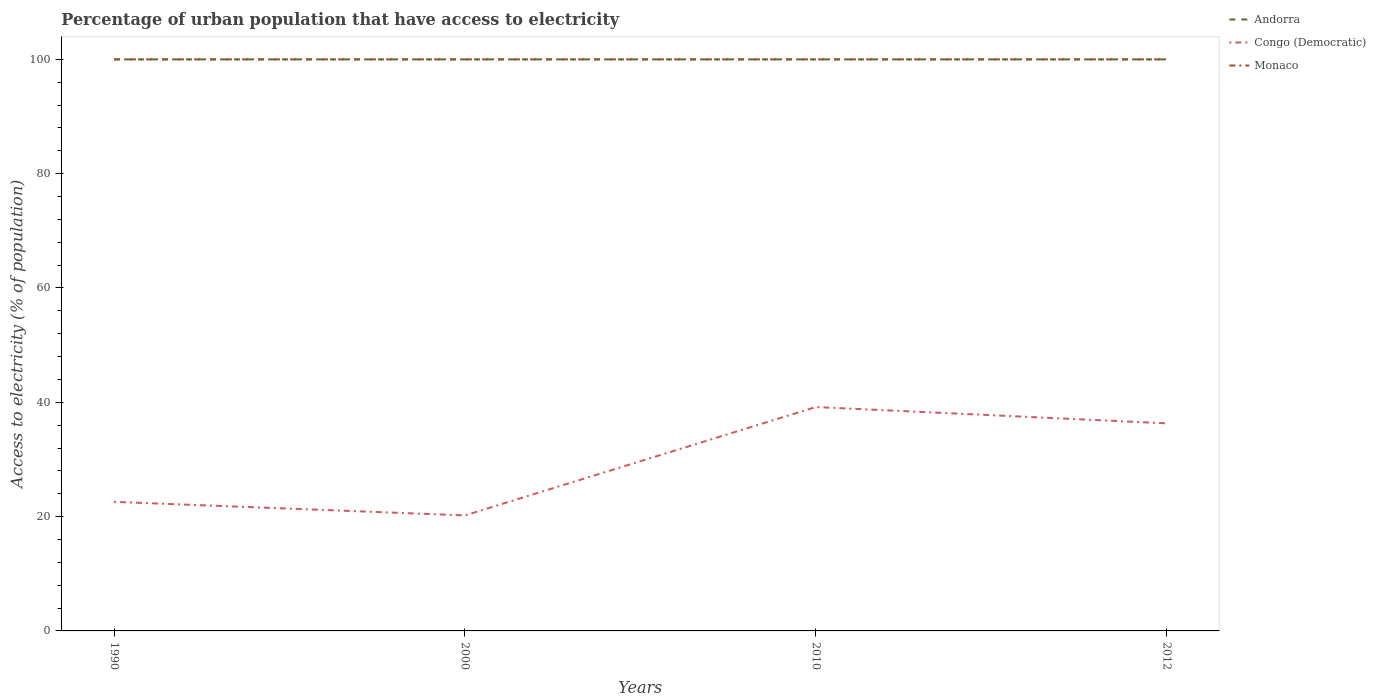How many different coloured lines are there?
Your response must be concise. 3. Does the line corresponding to Congo (Democratic) intersect with the line corresponding to Monaco?
Provide a succinct answer. No. Across all years, what is the maximum percentage of urban population that have access to electricity in Andorra?
Give a very brief answer. 100. What is the total percentage of urban population that have access to electricity in Andorra in the graph?
Ensure brevity in your answer.  0. What is the difference between the highest and the lowest percentage of urban population that have access to electricity in Andorra?
Your response must be concise. 0. Is the percentage of urban population that have access to electricity in Andorra strictly greater than the percentage of urban population that have access to electricity in Monaco over the years?
Your answer should be compact. No. What is the difference between two consecutive major ticks on the Y-axis?
Give a very brief answer. 20. Are the values on the major ticks of Y-axis written in scientific E-notation?
Your answer should be compact. No. What is the title of the graph?
Offer a very short reply. Percentage of urban population that have access to electricity. What is the label or title of the X-axis?
Keep it short and to the point. Years. What is the label or title of the Y-axis?
Keep it short and to the point. Access to electricity (% of population). What is the Access to electricity (% of population) in Congo (Democratic) in 1990?
Provide a succinct answer. 22.58. What is the Access to electricity (% of population) of Congo (Democratic) in 2000?
Your response must be concise. 20.21. What is the Access to electricity (% of population) in Monaco in 2000?
Offer a terse response. 100. What is the Access to electricity (% of population) in Congo (Democratic) in 2010?
Offer a very short reply. 39.17. What is the Access to electricity (% of population) in Andorra in 2012?
Ensure brevity in your answer.  100. What is the Access to electricity (% of population) of Congo (Democratic) in 2012?
Provide a succinct answer. 36.32. Across all years, what is the maximum Access to electricity (% of population) in Andorra?
Make the answer very short. 100. Across all years, what is the maximum Access to electricity (% of population) of Congo (Democratic)?
Give a very brief answer. 39.17. Across all years, what is the minimum Access to electricity (% of population) of Congo (Democratic)?
Offer a terse response. 20.21. What is the total Access to electricity (% of population) in Congo (Democratic) in the graph?
Offer a very short reply. 118.29. What is the difference between the Access to electricity (% of population) in Congo (Democratic) in 1990 and that in 2000?
Provide a short and direct response. 2.37. What is the difference between the Access to electricity (% of population) in Monaco in 1990 and that in 2000?
Your answer should be compact. 0. What is the difference between the Access to electricity (% of population) in Andorra in 1990 and that in 2010?
Ensure brevity in your answer.  0. What is the difference between the Access to electricity (% of population) of Congo (Democratic) in 1990 and that in 2010?
Provide a short and direct response. -16.59. What is the difference between the Access to electricity (% of population) of Monaco in 1990 and that in 2010?
Your response must be concise. 0. What is the difference between the Access to electricity (% of population) in Andorra in 1990 and that in 2012?
Your answer should be very brief. 0. What is the difference between the Access to electricity (% of population) in Congo (Democratic) in 1990 and that in 2012?
Provide a succinct answer. -13.73. What is the difference between the Access to electricity (% of population) of Congo (Democratic) in 2000 and that in 2010?
Keep it short and to the point. -18.96. What is the difference between the Access to electricity (% of population) of Monaco in 2000 and that in 2010?
Keep it short and to the point. 0. What is the difference between the Access to electricity (% of population) of Andorra in 2000 and that in 2012?
Provide a succinct answer. 0. What is the difference between the Access to electricity (% of population) in Congo (Democratic) in 2000 and that in 2012?
Give a very brief answer. -16.11. What is the difference between the Access to electricity (% of population) of Andorra in 2010 and that in 2012?
Offer a very short reply. 0. What is the difference between the Access to electricity (% of population) of Congo (Democratic) in 2010 and that in 2012?
Your answer should be very brief. 2.86. What is the difference between the Access to electricity (% of population) of Andorra in 1990 and the Access to electricity (% of population) of Congo (Democratic) in 2000?
Keep it short and to the point. 79.79. What is the difference between the Access to electricity (% of population) of Congo (Democratic) in 1990 and the Access to electricity (% of population) of Monaco in 2000?
Offer a terse response. -77.42. What is the difference between the Access to electricity (% of population) of Andorra in 1990 and the Access to electricity (% of population) of Congo (Democratic) in 2010?
Your answer should be very brief. 60.83. What is the difference between the Access to electricity (% of population) in Andorra in 1990 and the Access to electricity (% of population) in Monaco in 2010?
Your response must be concise. 0. What is the difference between the Access to electricity (% of population) of Congo (Democratic) in 1990 and the Access to electricity (% of population) of Monaco in 2010?
Give a very brief answer. -77.42. What is the difference between the Access to electricity (% of population) of Andorra in 1990 and the Access to electricity (% of population) of Congo (Democratic) in 2012?
Your answer should be compact. 63.68. What is the difference between the Access to electricity (% of population) of Congo (Democratic) in 1990 and the Access to electricity (% of population) of Monaco in 2012?
Provide a succinct answer. -77.42. What is the difference between the Access to electricity (% of population) in Andorra in 2000 and the Access to electricity (% of population) in Congo (Democratic) in 2010?
Your answer should be very brief. 60.83. What is the difference between the Access to electricity (% of population) of Andorra in 2000 and the Access to electricity (% of population) of Monaco in 2010?
Offer a terse response. 0. What is the difference between the Access to electricity (% of population) of Congo (Democratic) in 2000 and the Access to electricity (% of population) of Monaco in 2010?
Your response must be concise. -79.79. What is the difference between the Access to electricity (% of population) of Andorra in 2000 and the Access to electricity (% of population) of Congo (Democratic) in 2012?
Your answer should be compact. 63.68. What is the difference between the Access to electricity (% of population) of Congo (Democratic) in 2000 and the Access to electricity (% of population) of Monaco in 2012?
Provide a short and direct response. -79.79. What is the difference between the Access to electricity (% of population) in Andorra in 2010 and the Access to electricity (% of population) in Congo (Democratic) in 2012?
Your answer should be very brief. 63.68. What is the difference between the Access to electricity (% of population) of Congo (Democratic) in 2010 and the Access to electricity (% of population) of Monaco in 2012?
Offer a very short reply. -60.83. What is the average Access to electricity (% of population) of Andorra per year?
Provide a short and direct response. 100. What is the average Access to electricity (% of population) in Congo (Democratic) per year?
Give a very brief answer. 29.57. In the year 1990, what is the difference between the Access to electricity (% of population) of Andorra and Access to electricity (% of population) of Congo (Democratic)?
Provide a short and direct response. 77.42. In the year 1990, what is the difference between the Access to electricity (% of population) in Congo (Democratic) and Access to electricity (% of population) in Monaco?
Your response must be concise. -77.42. In the year 2000, what is the difference between the Access to electricity (% of population) of Andorra and Access to electricity (% of population) of Congo (Democratic)?
Your answer should be compact. 79.79. In the year 2000, what is the difference between the Access to electricity (% of population) of Congo (Democratic) and Access to electricity (% of population) of Monaco?
Keep it short and to the point. -79.79. In the year 2010, what is the difference between the Access to electricity (% of population) of Andorra and Access to electricity (% of population) of Congo (Democratic)?
Your answer should be compact. 60.83. In the year 2010, what is the difference between the Access to electricity (% of population) of Andorra and Access to electricity (% of population) of Monaco?
Provide a succinct answer. 0. In the year 2010, what is the difference between the Access to electricity (% of population) in Congo (Democratic) and Access to electricity (% of population) in Monaco?
Offer a very short reply. -60.83. In the year 2012, what is the difference between the Access to electricity (% of population) in Andorra and Access to electricity (% of population) in Congo (Democratic)?
Offer a very short reply. 63.68. In the year 2012, what is the difference between the Access to electricity (% of population) in Congo (Democratic) and Access to electricity (% of population) in Monaco?
Make the answer very short. -63.68. What is the ratio of the Access to electricity (% of population) of Andorra in 1990 to that in 2000?
Your answer should be compact. 1. What is the ratio of the Access to electricity (% of population) in Congo (Democratic) in 1990 to that in 2000?
Make the answer very short. 1.12. What is the ratio of the Access to electricity (% of population) in Monaco in 1990 to that in 2000?
Your answer should be very brief. 1. What is the ratio of the Access to electricity (% of population) in Andorra in 1990 to that in 2010?
Offer a very short reply. 1. What is the ratio of the Access to electricity (% of population) of Congo (Democratic) in 1990 to that in 2010?
Provide a succinct answer. 0.58. What is the ratio of the Access to electricity (% of population) in Monaco in 1990 to that in 2010?
Your answer should be very brief. 1. What is the ratio of the Access to electricity (% of population) of Congo (Democratic) in 1990 to that in 2012?
Provide a succinct answer. 0.62. What is the ratio of the Access to electricity (% of population) of Andorra in 2000 to that in 2010?
Make the answer very short. 1. What is the ratio of the Access to electricity (% of population) in Congo (Democratic) in 2000 to that in 2010?
Give a very brief answer. 0.52. What is the ratio of the Access to electricity (% of population) of Congo (Democratic) in 2000 to that in 2012?
Keep it short and to the point. 0.56. What is the ratio of the Access to electricity (% of population) in Congo (Democratic) in 2010 to that in 2012?
Give a very brief answer. 1.08. What is the ratio of the Access to electricity (% of population) of Monaco in 2010 to that in 2012?
Provide a succinct answer. 1. What is the difference between the highest and the second highest Access to electricity (% of population) of Congo (Democratic)?
Your answer should be very brief. 2.86. What is the difference between the highest and the lowest Access to electricity (% of population) of Congo (Democratic)?
Offer a very short reply. 18.96. What is the difference between the highest and the lowest Access to electricity (% of population) in Monaco?
Provide a short and direct response. 0. 